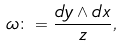Convert formula to latex. <formula><loc_0><loc_0><loc_500><loc_500>\omega \colon = \frac { d y \wedge d x } { z } ,</formula> 